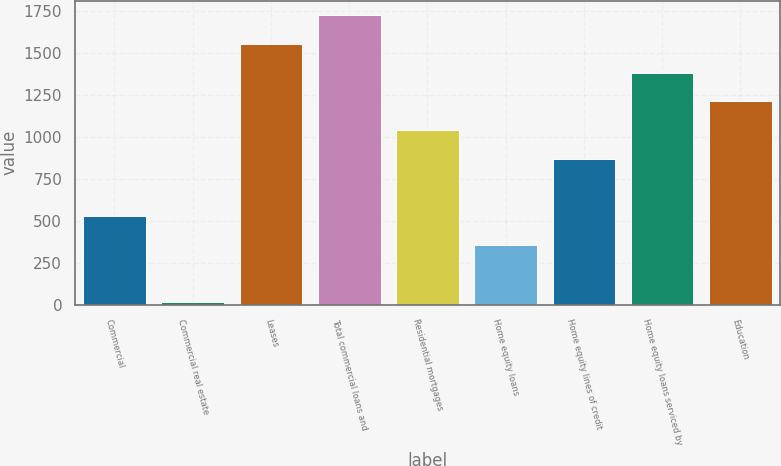Convert chart to OTSL. <chart><loc_0><loc_0><loc_500><loc_500><bar_chart><fcel>Commercial<fcel>Commercial real estate<fcel>Leases<fcel>Total commercial loans and<fcel>Residential mortgages<fcel>Home equity loans<fcel>Home equity lines of credit<fcel>Home equity loans serviced by<fcel>Education<nl><fcel>527.9<fcel>14<fcel>1555.7<fcel>1727<fcel>1041.8<fcel>356.6<fcel>870.5<fcel>1384.4<fcel>1213.1<nl></chart> 